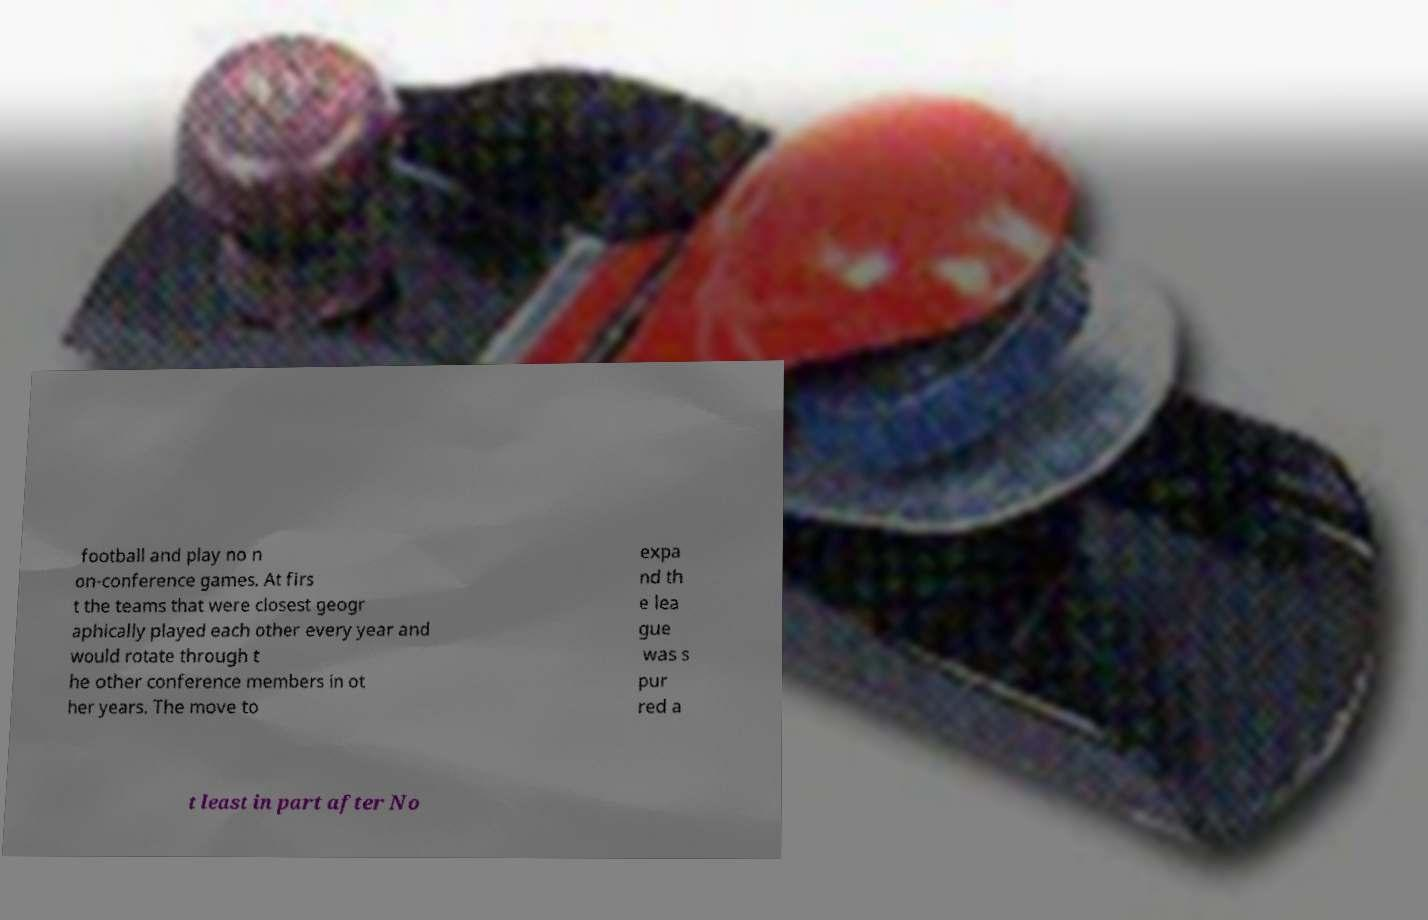What messages or text are displayed in this image? I need them in a readable, typed format. football and play no n on-conference games. At firs t the teams that were closest geogr aphically played each other every year and would rotate through t he other conference members in ot her years. The move to expa nd th e lea gue was s pur red a t least in part after No 